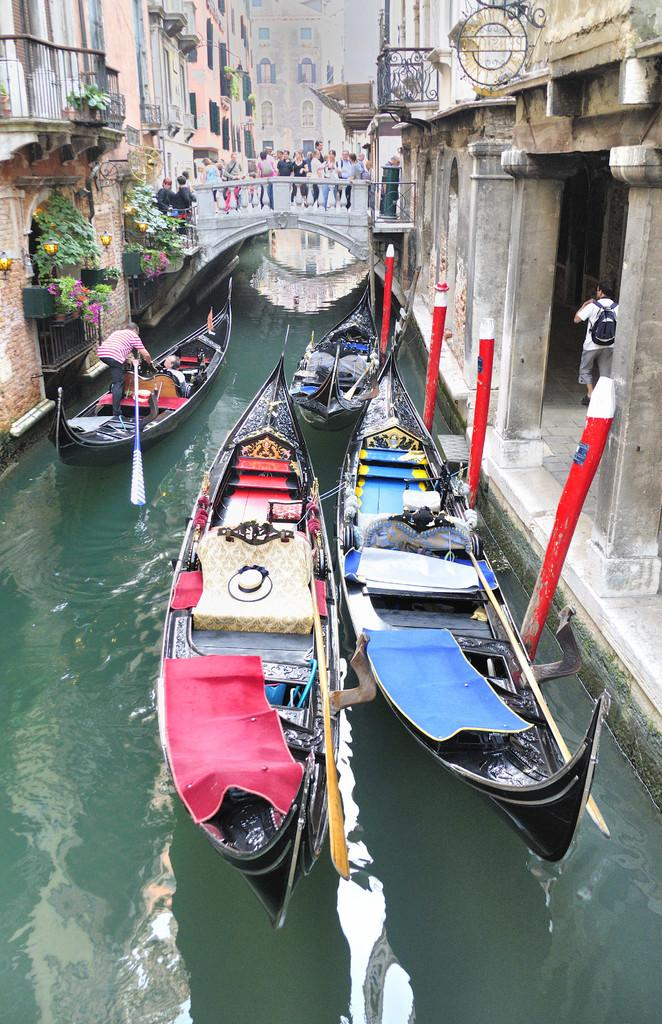What is on the water in the image? There are boats on the water in the image. What are the people doing in the image? People are standing on a bridge in the image. What can be seen on the right side of the image? There are buildings on the right side of the image. What can be seen on the left side of the image? There are buildings on the left side of the image. What type of current can be seen in the water in the image? There is no current visible in the water in the image; it appears to be calm. Can you see a pail being used by someone in the image? There is no pail present in the image. 